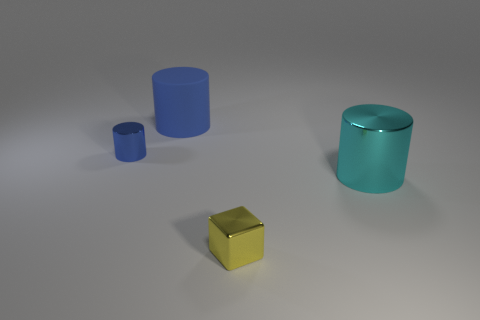Do the tiny cylinder and the large object behind the large cyan object have the same color?
Make the answer very short. Yes. What is the color of the metal cylinder behind the big cylinder on the right side of the big thing that is behind the cyan metallic thing?
Provide a succinct answer. Blue. What is the color of the large shiny object that is the same shape as the big blue rubber thing?
Your response must be concise. Cyan. Are there the same number of cyan metallic cylinders that are in front of the cyan metallic cylinder and big rubber balls?
Make the answer very short. Yes. How many spheres are either blue things or large matte objects?
Your response must be concise. 0. There is a small cylinder that is the same material as the small yellow object; what is its color?
Offer a terse response. Blue. Is the material of the block the same as the object that is on the left side of the blue rubber cylinder?
Offer a terse response. Yes. What number of things are large objects or shiny blocks?
Ensure brevity in your answer.  3. There is a cylinder that is the same color as the large rubber object; what is it made of?
Your answer should be very brief. Metal. Is there another blue object that has the same shape as the blue rubber thing?
Give a very brief answer. Yes. 